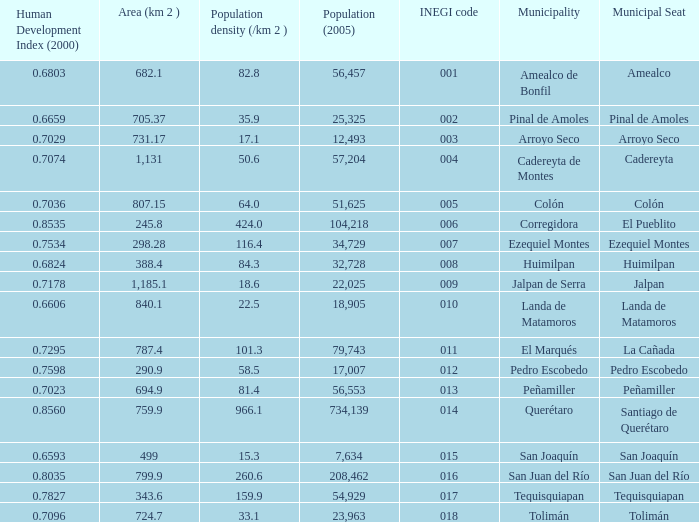WHat is the amount of Human Development Index (2000) that has a Population (2005) of 54,929, and an Area (km 2 ) larger than 343.6? 0.0. 